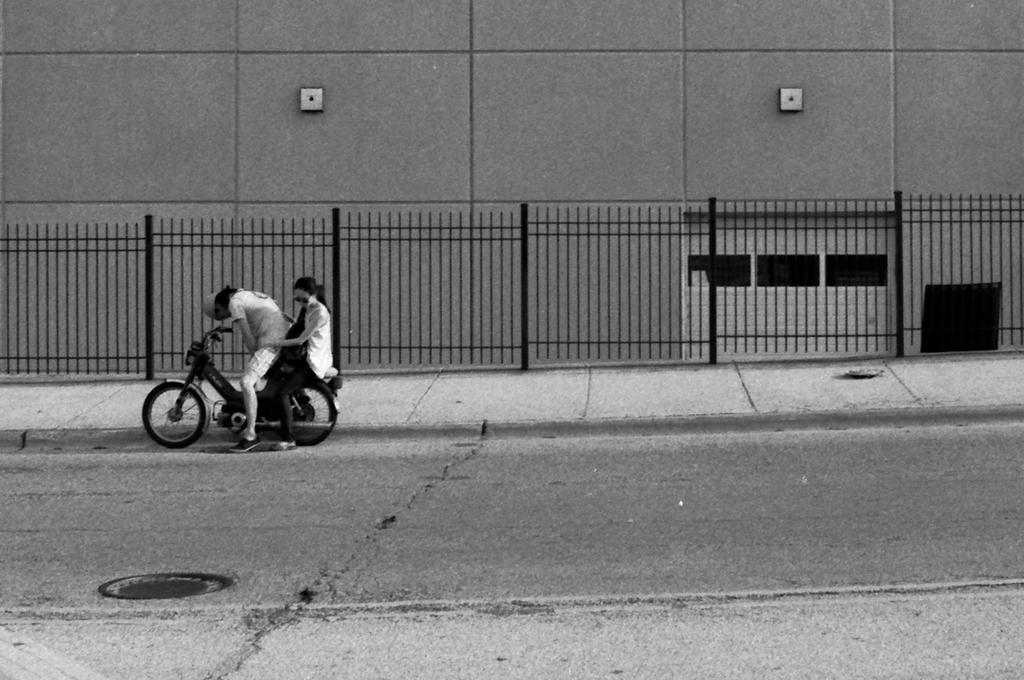How many people are sitting on the vehicle in the image? There are two persons sitting on the vehicle in the image. What is one person doing while sitting on the vehicle? One person is holding the vehicle. What type of pathway can be seen in the image? There is a road in the image. What type of barrier is present in the image? There is a fence in the image. What type of structure can be seen in the background of the image? There is a wall in the image. How many men are standing on the shelf in the image? There are no men or shelves present in the image. 